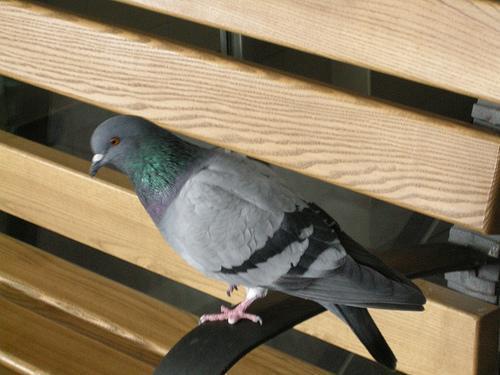How many benches are there?
Give a very brief answer. 1. How many birds are there?
Give a very brief answer. 1. 